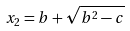Convert formula to latex. <formula><loc_0><loc_0><loc_500><loc_500>x _ { 2 } = b + \sqrt { b ^ { 2 } - c }</formula> 